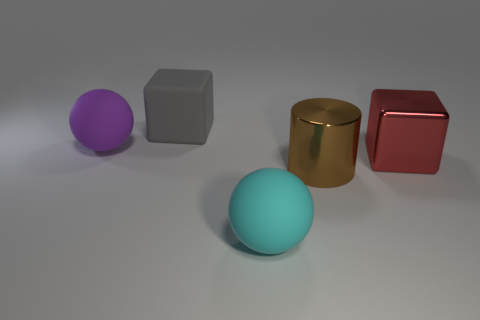What number of large cyan rubber objects are there?
Keep it short and to the point. 1. The big sphere left of the block that is left of the big sphere that is on the right side of the large gray object is made of what material?
Make the answer very short. Rubber. There is a large shiny thing on the left side of the red metallic cube; how many big red blocks are in front of it?
Your answer should be very brief. 0. The other object that is the same shape as the big red object is what color?
Make the answer very short. Gray. Is the red cube made of the same material as the purple sphere?
Give a very brief answer. No. How many cylinders are big yellow metallic objects or metallic objects?
Your answer should be very brief. 1. There is a block right of the big rubber thing in front of the matte sphere behind the large metal cylinder; what size is it?
Your answer should be very brief. Large. What size is the gray matte object that is the same shape as the red thing?
Your response must be concise. Large. How many brown cylinders are on the left side of the big gray object?
Make the answer very short. 0. Is the color of the large metallic thing to the left of the red thing the same as the large metallic cube?
Make the answer very short. No. 